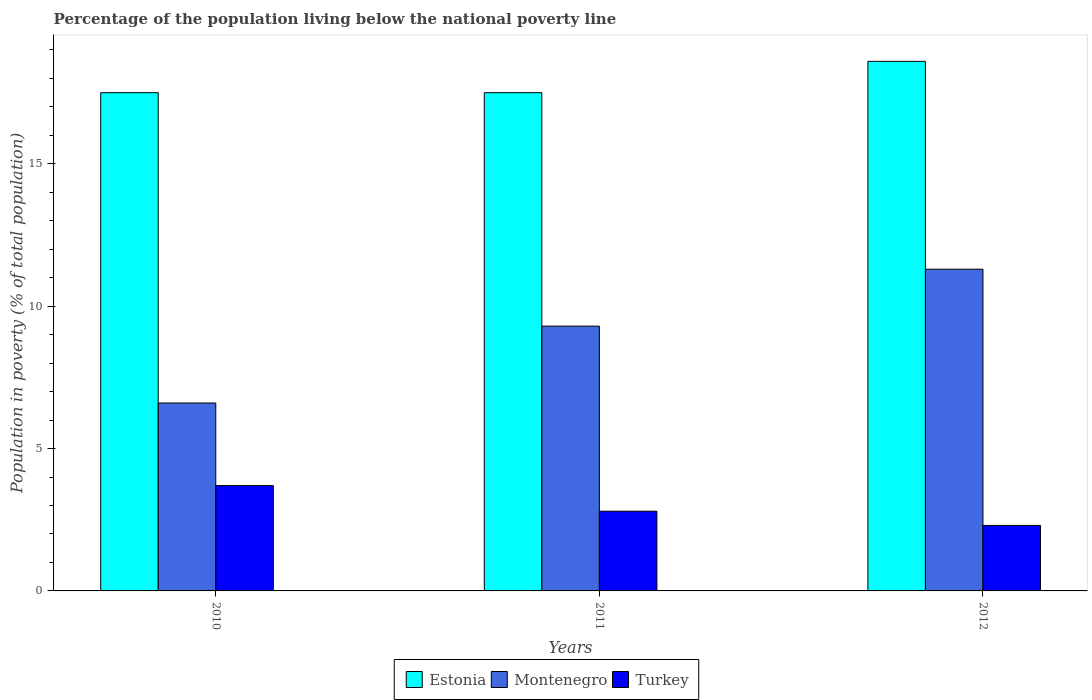How many groups of bars are there?
Keep it short and to the point. 3. Are the number of bars per tick equal to the number of legend labels?
Provide a short and direct response. Yes. Are the number of bars on each tick of the X-axis equal?
Provide a succinct answer. Yes. Across all years, what is the maximum percentage of the population living below the national poverty line in Estonia?
Offer a very short reply. 18.6. Across all years, what is the minimum percentage of the population living below the national poverty line in Estonia?
Make the answer very short. 17.5. What is the total percentage of the population living below the national poverty line in Turkey in the graph?
Your answer should be compact. 8.8. What is the difference between the percentage of the population living below the national poverty line in Turkey in 2010 and that in 2012?
Make the answer very short. 1.4. What is the difference between the percentage of the population living below the national poverty line in Estonia in 2010 and the percentage of the population living below the national poverty line in Montenegro in 2012?
Provide a short and direct response. 6.2. What is the average percentage of the population living below the national poverty line in Turkey per year?
Your answer should be very brief. 2.93. In the year 2010, what is the difference between the percentage of the population living below the national poverty line in Turkey and percentage of the population living below the national poverty line in Montenegro?
Your response must be concise. -2.9. In how many years, is the percentage of the population living below the national poverty line in Montenegro greater than 15 %?
Give a very brief answer. 0. What is the ratio of the percentage of the population living below the national poverty line in Turkey in 2010 to that in 2011?
Offer a terse response. 1.32. Is the percentage of the population living below the national poverty line in Turkey in 2010 less than that in 2012?
Your answer should be very brief. No. Is the difference between the percentage of the population living below the national poverty line in Turkey in 2010 and 2012 greater than the difference between the percentage of the population living below the national poverty line in Montenegro in 2010 and 2012?
Keep it short and to the point. Yes. What is the difference between the highest and the second highest percentage of the population living below the national poverty line in Estonia?
Your answer should be compact. 1.1. What is the difference between the highest and the lowest percentage of the population living below the national poverty line in Turkey?
Your answer should be compact. 1.4. What does the 2nd bar from the left in 2010 represents?
Make the answer very short. Montenegro. How many bars are there?
Your response must be concise. 9. Are the values on the major ticks of Y-axis written in scientific E-notation?
Keep it short and to the point. No. Does the graph contain grids?
Provide a succinct answer. No. Where does the legend appear in the graph?
Offer a very short reply. Bottom center. How many legend labels are there?
Make the answer very short. 3. How are the legend labels stacked?
Offer a terse response. Horizontal. What is the title of the graph?
Provide a succinct answer. Percentage of the population living below the national poverty line. Does "Middle East & North Africa (developing only)" appear as one of the legend labels in the graph?
Your response must be concise. No. What is the label or title of the X-axis?
Your answer should be compact. Years. What is the label or title of the Y-axis?
Give a very brief answer. Population in poverty (% of total population). What is the Population in poverty (% of total population) of Estonia in 2010?
Your answer should be very brief. 17.5. What is the Population in poverty (% of total population) in Estonia in 2011?
Offer a terse response. 17.5. What is the Population in poverty (% of total population) of Montenegro in 2011?
Provide a succinct answer. 9.3. What is the Population in poverty (% of total population) in Montenegro in 2012?
Keep it short and to the point. 11.3. Across all years, what is the maximum Population in poverty (% of total population) in Montenegro?
Your answer should be very brief. 11.3. Across all years, what is the maximum Population in poverty (% of total population) in Turkey?
Make the answer very short. 3.7. Across all years, what is the minimum Population in poverty (% of total population) in Montenegro?
Provide a succinct answer. 6.6. What is the total Population in poverty (% of total population) in Estonia in the graph?
Provide a succinct answer. 53.6. What is the total Population in poverty (% of total population) of Montenegro in the graph?
Give a very brief answer. 27.2. What is the difference between the Population in poverty (% of total population) of Estonia in 2010 and that in 2012?
Your answer should be very brief. -1.1. What is the difference between the Population in poverty (% of total population) in Montenegro in 2010 and that in 2012?
Provide a short and direct response. -4.7. What is the difference between the Population in poverty (% of total population) in Montenegro in 2011 and that in 2012?
Give a very brief answer. -2. What is the difference between the Population in poverty (% of total population) in Estonia in 2010 and the Population in poverty (% of total population) in Montenegro in 2011?
Provide a succinct answer. 8.2. What is the difference between the Population in poverty (% of total population) in Montenegro in 2010 and the Population in poverty (% of total population) in Turkey in 2011?
Provide a succinct answer. 3.8. What is the difference between the Population in poverty (% of total population) of Estonia in 2010 and the Population in poverty (% of total population) of Montenegro in 2012?
Your answer should be compact. 6.2. What is the difference between the Population in poverty (% of total population) of Montenegro in 2010 and the Population in poverty (% of total population) of Turkey in 2012?
Offer a terse response. 4.3. What is the difference between the Population in poverty (% of total population) in Montenegro in 2011 and the Population in poverty (% of total population) in Turkey in 2012?
Offer a very short reply. 7. What is the average Population in poverty (% of total population) of Estonia per year?
Provide a short and direct response. 17.87. What is the average Population in poverty (% of total population) of Montenegro per year?
Ensure brevity in your answer.  9.07. What is the average Population in poverty (% of total population) in Turkey per year?
Your response must be concise. 2.93. In the year 2010, what is the difference between the Population in poverty (% of total population) of Estonia and Population in poverty (% of total population) of Turkey?
Your answer should be compact. 13.8. In the year 2011, what is the difference between the Population in poverty (% of total population) in Estonia and Population in poverty (% of total population) in Turkey?
Your answer should be compact. 14.7. In the year 2012, what is the difference between the Population in poverty (% of total population) of Estonia and Population in poverty (% of total population) of Montenegro?
Offer a terse response. 7.3. In the year 2012, what is the difference between the Population in poverty (% of total population) of Montenegro and Population in poverty (% of total population) of Turkey?
Ensure brevity in your answer.  9. What is the ratio of the Population in poverty (% of total population) in Estonia in 2010 to that in 2011?
Your answer should be very brief. 1. What is the ratio of the Population in poverty (% of total population) of Montenegro in 2010 to that in 2011?
Give a very brief answer. 0.71. What is the ratio of the Population in poverty (% of total population) in Turkey in 2010 to that in 2011?
Provide a succinct answer. 1.32. What is the ratio of the Population in poverty (% of total population) of Estonia in 2010 to that in 2012?
Keep it short and to the point. 0.94. What is the ratio of the Population in poverty (% of total population) in Montenegro in 2010 to that in 2012?
Give a very brief answer. 0.58. What is the ratio of the Population in poverty (% of total population) in Turkey in 2010 to that in 2012?
Your answer should be very brief. 1.61. What is the ratio of the Population in poverty (% of total population) in Estonia in 2011 to that in 2012?
Offer a very short reply. 0.94. What is the ratio of the Population in poverty (% of total population) in Montenegro in 2011 to that in 2012?
Offer a very short reply. 0.82. What is the ratio of the Population in poverty (% of total population) in Turkey in 2011 to that in 2012?
Give a very brief answer. 1.22. What is the difference between the highest and the second highest Population in poverty (% of total population) of Estonia?
Make the answer very short. 1.1. What is the difference between the highest and the second highest Population in poverty (% of total population) of Montenegro?
Make the answer very short. 2. What is the difference between the highest and the lowest Population in poverty (% of total population) in Estonia?
Give a very brief answer. 1.1. 